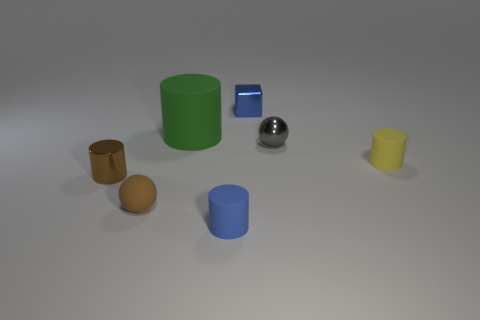Add 1 tiny yellow rubber things. How many objects exist? 8 Subtract all cylinders. How many objects are left? 3 Subtract 0 purple cubes. How many objects are left? 7 Subtract all green things. Subtract all large things. How many objects are left? 5 Add 1 small blue cylinders. How many small blue cylinders are left? 2 Add 1 tiny yellow objects. How many tiny yellow objects exist? 2 